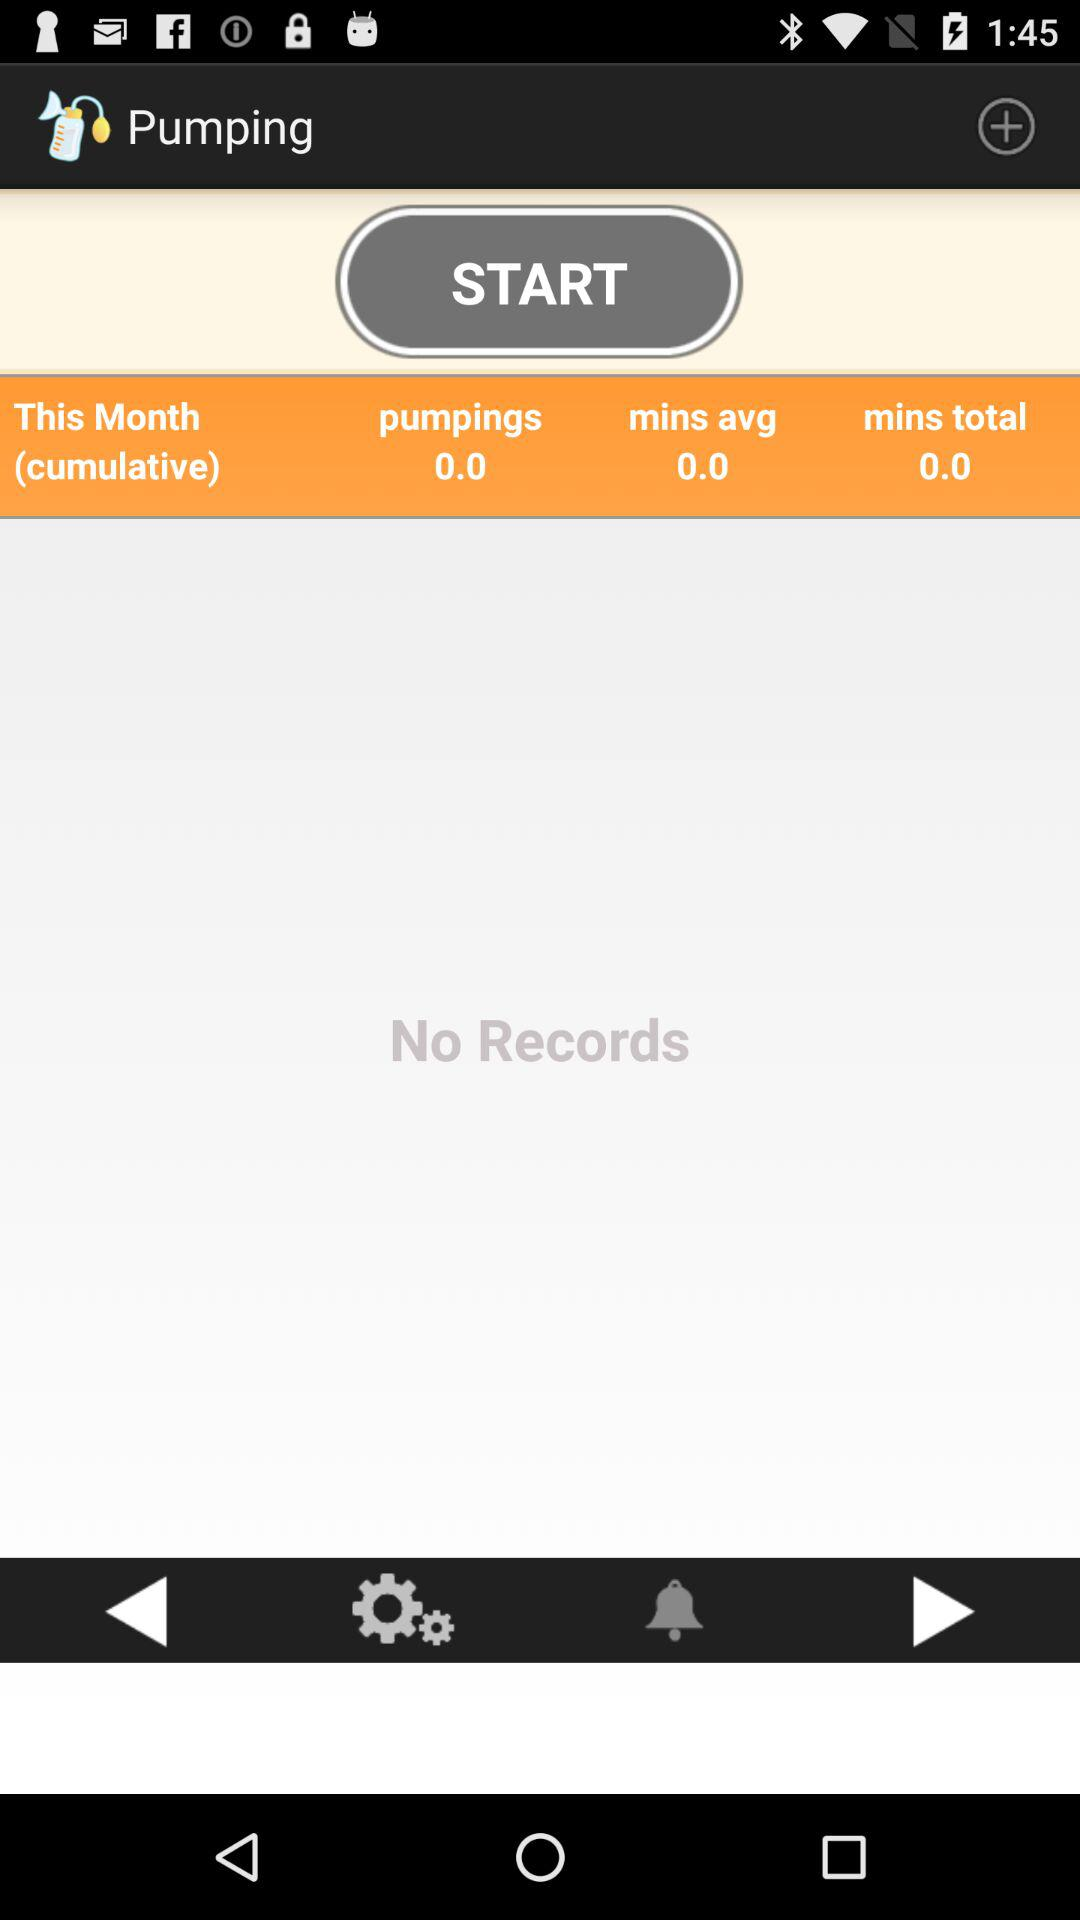How much were the cumulative pumpings for the previous month?
When the provided information is insufficient, respond with <no answer>. <no answer> 